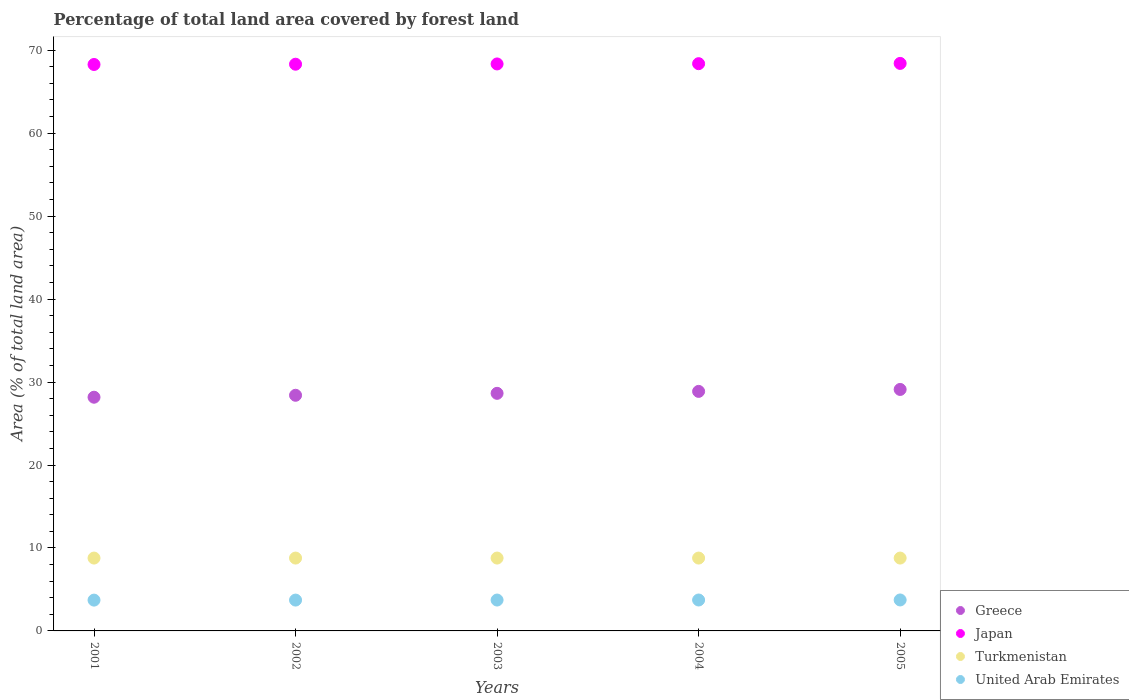Is the number of dotlines equal to the number of legend labels?
Offer a terse response. Yes. What is the percentage of forest land in Turkmenistan in 2003?
Keep it short and to the point. 8.78. Across all years, what is the maximum percentage of forest land in Greece?
Provide a succinct answer. 29.11. Across all years, what is the minimum percentage of forest land in United Arab Emirates?
Offer a very short reply. 3.71. In which year was the percentage of forest land in Greece maximum?
Your answer should be very brief. 2005. What is the total percentage of forest land in United Arab Emirates in the graph?
Make the answer very short. 18.61. What is the difference between the percentage of forest land in Greece in 2004 and that in 2005?
Your response must be concise. -0.23. What is the difference between the percentage of forest land in Greece in 2003 and the percentage of forest land in Japan in 2001?
Make the answer very short. -39.64. What is the average percentage of forest land in Greece per year?
Ensure brevity in your answer.  28.64. In the year 2005, what is the difference between the percentage of forest land in Greece and percentage of forest land in Turkmenistan?
Provide a short and direct response. 20.33. In how many years, is the percentage of forest land in Turkmenistan greater than 26 %?
Your answer should be very brief. 0. What is the ratio of the percentage of forest land in Turkmenistan in 2002 to that in 2004?
Give a very brief answer. 1. Is the percentage of forest land in Japan in 2002 less than that in 2005?
Ensure brevity in your answer.  Yes. What is the difference between the highest and the second highest percentage of forest land in Greece?
Make the answer very short. 0.23. What is the difference between the highest and the lowest percentage of forest land in United Arab Emirates?
Your answer should be compact. 0.02. Is it the case that in every year, the sum of the percentage of forest land in United Arab Emirates and percentage of forest land in Japan  is greater than the sum of percentage of forest land in Greece and percentage of forest land in Turkmenistan?
Your answer should be very brief. Yes. Is it the case that in every year, the sum of the percentage of forest land in Turkmenistan and percentage of forest land in Japan  is greater than the percentage of forest land in Greece?
Ensure brevity in your answer.  Yes. Does the percentage of forest land in Turkmenistan monotonically increase over the years?
Give a very brief answer. No. Is the percentage of forest land in Japan strictly greater than the percentage of forest land in Turkmenistan over the years?
Provide a short and direct response. Yes. How many years are there in the graph?
Your answer should be very brief. 5. Does the graph contain grids?
Your answer should be compact. No. What is the title of the graph?
Your response must be concise. Percentage of total land area covered by forest land. Does "Azerbaijan" appear as one of the legend labels in the graph?
Ensure brevity in your answer.  No. What is the label or title of the Y-axis?
Your response must be concise. Area (% of total land area). What is the Area (% of total land area) of Greece in 2001?
Offer a terse response. 28.17. What is the Area (% of total land area) of Japan in 2001?
Ensure brevity in your answer.  68.28. What is the Area (% of total land area) of Turkmenistan in 2001?
Your response must be concise. 8.78. What is the Area (% of total land area) of United Arab Emirates in 2001?
Ensure brevity in your answer.  3.71. What is the Area (% of total land area) of Greece in 2002?
Provide a succinct answer. 28.4. What is the Area (% of total land area) of Japan in 2002?
Offer a terse response. 68.31. What is the Area (% of total land area) of Turkmenistan in 2002?
Provide a short and direct response. 8.78. What is the Area (% of total land area) in United Arab Emirates in 2002?
Provide a short and direct response. 3.72. What is the Area (% of total land area) in Greece in 2003?
Your response must be concise. 28.64. What is the Area (% of total land area) in Japan in 2003?
Make the answer very short. 68.34. What is the Area (% of total land area) in Turkmenistan in 2003?
Keep it short and to the point. 8.78. What is the Area (% of total land area) of United Arab Emirates in 2003?
Your answer should be compact. 3.72. What is the Area (% of total land area) in Greece in 2004?
Provide a short and direct response. 28.87. What is the Area (% of total land area) of Japan in 2004?
Keep it short and to the point. 68.38. What is the Area (% of total land area) in Turkmenistan in 2004?
Your answer should be compact. 8.78. What is the Area (% of total land area) in United Arab Emirates in 2004?
Ensure brevity in your answer.  3.73. What is the Area (% of total land area) in Greece in 2005?
Ensure brevity in your answer.  29.11. What is the Area (% of total land area) of Japan in 2005?
Offer a very short reply. 68.41. What is the Area (% of total land area) in Turkmenistan in 2005?
Keep it short and to the point. 8.78. What is the Area (% of total land area) in United Arab Emirates in 2005?
Make the answer very short. 3.73. Across all years, what is the maximum Area (% of total land area) of Greece?
Provide a short and direct response. 29.11. Across all years, what is the maximum Area (% of total land area) in Japan?
Provide a short and direct response. 68.41. Across all years, what is the maximum Area (% of total land area) in Turkmenistan?
Keep it short and to the point. 8.78. Across all years, what is the maximum Area (% of total land area) of United Arab Emirates?
Give a very brief answer. 3.73. Across all years, what is the minimum Area (% of total land area) of Greece?
Provide a short and direct response. 28.17. Across all years, what is the minimum Area (% of total land area) in Japan?
Ensure brevity in your answer.  68.28. Across all years, what is the minimum Area (% of total land area) in Turkmenistan?
Your answer should be compact. 8.78. Across all years, what is the minimum Area (% of total land area) of United Arab Emirates?
Keep it short and to the point. 3.71. What is the total Area (% of total land area) of Greece in the graph?
Your answer should be very brief. 143.2. What is the total Area (% of total land area) in Japan in the graph?
Make the answer very short. 341.72. What is the total Area (% of total land area) in Turkmenistan in the graph?
Ensure brevity in your answer.  43.91. What is the total Area (% of total land area) in United Arab Emirates in the graph?
Give a very brief answer. 18.61. What is the difference between the Area (% of total land area) in Greece in 2001 and that in 2002?
Keep it short and to the point. -0.23. What is the difference between the Area (% of total land area) of Japan in 2001 and that in 2002?
Your answer should be compact. -0.03. What is the difference between the Area (% of total land area) in Turkmenistan in 2001 and that in 2002?
Give a very brief answer. 0. What is the difference between the Area (% of total land area) of United Arab Emirates in 2001 and that in 2002?
Keep it short and to the point. -0. What is the difference between the Area (% of total land area) in Greece in 2001 and that in 2003?
Offer a very short reply. -0.47. What is the difference between the Area (% of total land area) of Japan in 2001 and that in 2003?
Provide a succinct answer. -0.06. What is the difference between the Area (% of total land area) of Turkmenistan in 2001 and that in 2003?
Keep it short and to the point. 0. What is the difference between the Area (% of total land area) in United Arab Emirates in 2001 and that in 2003?
Ensure brevity in your answer.  -0.01. What is the difference between the Area (% of total land area) in Greece in 2001 and that in 2004?
Provide a short and direct response. -0.7. What is the difference between the Area (% of total land area) in Japan in 2001 and that in 2004?
Give a very brief answer. -0.1. What is the difference between the Area (% of total land area) in United Arab Emirates in 2001 and that in 2004?
Keep it short and to the point. -0.01. What is the difference between the Area (% of total land area) of Greece in 2001 and that in 2005?
Your answer should be compact. -0.94. What is the difference between the Area (% of total land area) in Japan in 2001 and that in 2005?
Make the answer very short. -0.13. What is the difference between the Area (% of total land area) of United Arab Emirates in 2001 and that in 2005?
Your answer should be very brief. -0.02. What is the difference between the Area (% of total land area) of Greece in 2002 and that in 2003?
Keep it short and to the point. -0.23. What is the difference between the Area (% of total land area) in Japan in 2002 and that in 2003?
Keep it short and to the point. -0.03. What is the difference between the Area (% of total land area) in United Arab Emirates in 2002 and that in 2003?
Provide a short and direct response. -0. What is the difference between the Area (% of total land area) of Greece in 2002 and that in 2004?
Offer a very short reply. -0.47. What is the difference between the Area (% of total land area) in Japan in 2002 and that in 2004?
Your answer should be compact. -0.06. What is the difference between the Area (% of total land area) of United Arab Emirates in 2002 and that in 2004?
Provide a short and direct response. -0.01. What is the difference between the Area (% of total land area) of Greece in 2002 and that in 2005?
Keep it short and to the point. -0.7. What is the difference between the Area (% of total land area) of Japan in 2002 and that in 2005?
Your response must be concise. -0.1. What is the difference between the Area (% of total land area) of Turkmenistan in 2002 and that in 2005?
Your answer should be very brief. 0. What is the difference between the Area (% of total land area) in United Arab Emirates in 2002 and that in 2005?
Your response must be concise. -0.01. What is the difference between the Area (% of total land area) of Greece in 2003 and that in 2004?
Provide a short and direct response. -0.23. What is the difference between the Area (% of total land area) of Japan in 2003 and that in 2004?
Ensure brevity in your answer.  -0.03. What is the difference between the Area (% of total land area) in Turkmenistan in 2003 and that in 2004?
Offer a terse response. 0. What is the difference between the Area (% of total land area) of United Arab Emirates in 2003 and that in 2004?
Your response must be concise. -0. What is the difference between the Area (% of total land area) in Greece in 2003 and that in 2005?
Provide a succinct answer. -0.47. What is the difference between the Area (% of total land area) of Japan in 2003 and that in 2005?
Your response must be concise. -0.06. What is the difference between the Area (% of total land area) in Turkmenistan in 2003 and that in 2005?
Give a very brief answer. 0. What is the difference between the Area (% of total land area) in United Arab Emirates in 2003 and that in 2005?
Offer a terse response. -0.01. What is the difference between the Area (% of total land area) in Greece in 2004 and that in 2005?
Provide a succinct answer. -0.23. What is the difference between the Area (% of total land area) in Japan in 2004 and that in 2005?
Your response must be concise. -0.03. What is the difference between the Area (% of total land area) in Turkmenistan in 2004 and that in 2005?
Your answer should be very brief. 0. What is the difference between the Area (% of total land area) of United Arab Emirates in 2004 and that in 2005?
Provide a short and direct response. -0. What is the difference between the Area (% of total land area) in Greece in 2001 and the Area (% of total land area) in Japan in 2002?
Make the answer very short. -40.14. What is the difference between the Area (% of total land area) in Greece in 2001 and the Area (% of total land area) in Turkmenistan in 2002?
Ensure brevity in your answer.  19.39. What is the difference between the Area (% of total land area) in Greece in 2001 and the Area (% of total land area) in United Arab Emirates in 2002?
Give a very brief answer. 24.45. What is the difference between the Area (% of total land area) in Japan in 2001 and the Area (% of total land area) in Turkmenistan in 2002?
Your response must be concise. 59.5. What is the difference between the Area (% of total land area) in Japan in 2001 and the Area (% of total land area) in United Arab Emirates in 2002?
Ensure brevity in your answer.  64.56. What is the difference between the Area (% of total land area) of Turkmenistan in 2001 and the Area (% of total land area) of United Arab Emirates in 2002?
Offer a very short reply. 5.06. What is the difference between the Area (% of total land area) in Greece in 2001 and the Area (% of total land area) in Japan in 2003?
Provide a succinct answer. -40.17. What is the difference between the Area (% of total land area) of Greece in 2001 and the Area (% of total land area) of Turkmenistan in 2003?
Provide a succinct answer. 19.39. What is the difference between the Area (% of total land area) in Greece in 2001 and the Area (% of total land area) in United Arab Emirates in 2003?
Provide a succinct answer. 24.45. What is the difference between the Area (% of total land area) of Japan in 2001 and the Area (% of total land area) of Turkmenistan in 2003?
Offer a very short reply. 59.5. What is the difference between the Area (% of total land area) in Japan in 2001 and the Area (% of total land area) in United Arab Emirates in 2003?
Keep it short and to the point. 64.56. What is the difference between the Area (% of total land area) of Turkmenistan in 2001 and the Area (% of total land area) of United Arab Emirates in 2003?
Make the answer very short. 5.06. What is the difference between the Area (% of total land area) of Greece in 2001 and the Area (% of total land area) of Japan in 2004?
Your answer should be very brief. -40.21. What is the difference between the Area (% of total land area) of Greece in 2001 and the Area (% of total land area) of Turkmenistan in 2004?
Offer a terse response. 19.39. What is the difference between the Area (% of total land area) of Greece in 2001 and the Area (% of total land area) of United Arab Emirates in 2004?
Your answer should be compact. 24.44. What is the difference between the Area (% of total land area) of Japan in 2001 and the Area (% of total land area) of Turkmenistan in 2004?
Make the answer very short. 59.5. What is the difference between the Area (% of total land area) of Japan in 2001 and the Area (% of total land area) of United Arab Emirates in 2004?
Ensure brevity in your answer.  64.55. What is the difference between the Area (% of total land area) of Turkmenistan in 2001 and the Area (% of total land area) of United Arab Emirates in 2004?
Give a very brief answer. 5.05. What is the difference between the Area (% of total land area) in Greece in 2001 and the Area (% of total land area) in Japan in 2005?
Your answer should be very brief. -40.24. What is the difference between the Area (% of total land area) in Greece in 2001 and the Area (% of total land area) in Turkmenistan in 2005?
Your answer should be very brief. 19.39. What is the difference between the Area (% of total land area) in Greece in 2001 and the Area (% of total land area) in United Arab Emirates in 2005?
Your answer should be very brief. 24.44. What is the difference between the Area (% of total land area) in Japan in 2001 and the Area (% of total land area) in Turkmenistan in 2005?
Your answer should be very brief. 59.5. What is the difference between the Area (% of total land area) in Japan in 2001 and the Area (% of total land area) in United Arab Emirates in 2005?
Ensure brevity in your answer.  64.55. What is the difference between the Area (% of total land area) of Turkmenistan in 2001 and the Area (% of total land area) of United Arab Emirates in 2005?
Provide a succinct answer. 5.05. What is the difference between the Area (% of total land area) in Greece in 2002 and the Area (% of total land area) in Japan in 2003?
Provide a succinct answer. -39.94. What is the difference between the Area (% of total land area) in Greece in 2002 and the Area (% of total land area) in Turkmenistan in 2003?
Ensure brevity in your answer.  19.62. What is the difference between the Area (% of total land area) of Greece in 2002 and the Area (% of total land area) of United Arab Emirates in 2003?
Your answer should be compact. 24.68. What is the difference between the Area (% of total land area) in Japan in 2002 and the Area (% of total land area) in Turkmenistan in 2003?
Ensure brevity in your answer.  59.53. What is the difference between the Area (% of total land area) of Japan in 2002 and the Area (% of total land area) of United Arab Emirates in 2003?
Offer a very short reply. 64.59. What is the difference between the Area (% of total land area) of Turkmenistan in 2002 and the Area (% of total land area) of United Arab Emirates in 2003?
Provide a succinct answer. 5.06. What is the difference between the Area (% of total land area) of Greece in 2002 and the Area (% of total land area) of Japan in 2004?
Make the answer very short. -39.97. What is the difference between the Area (% of total land area) of Greece in 2002 and the Area (% of total land area) of Turkmenistan in 2004?
Your answer should be very brief. 19.62. What is the difference between the Area (% of total land area) in Greece in 2002 and the Area (% of total land area) in United Arab Emirates in 2004?
Give a very brief answer. 24.68. What is the difference between the Area (% of total land area) of Japan in 2002 and the Area (% of total land area) of Turkmenistan in 2004?
Offer a very short reply. 59.53. What is the difference between the Area (% of total land area) in Japan in 2002 and the Area (% of total land area) in United Arab Emirates in 2004?
Your answer should be compact. 64.58. What is the difference between the Area (% of total land area) of Turkmenistan in 2002 and the Area (% of total land area) of United Arab Emirates in 2004?
Your response must be concise. 5.05. What is the difference between the Area (% of total land area) in Greece in 2002 and the Area (% of total land area) in Japan in 2005?
Offer a terse response. -40. What is the difference between the Area (% of total land area) in Greece in 2002 and the Area (% of total land area) in Turkmenistan in 2005?
Make the answer very short. 19.62. What is the difference between the Area (% of total land area) in Greece in 2002 and the Area (% of total land area) in United Arab Emirates in 2005?
Your answer should be compact. 24.67. What is the difference between the Area (% of total land area) of Japan in 2002 and the Area (% of total land area) of Turkmenistan in 2005?
Ensure brevity in your answer.  59.53. What is the difference between the Area (% of total land area) of Japan in 2002 and the Area (% of total land area) of United Arab Emirates in 2005?
Your response must be concise. 64.58. What is the difference between the Area (% of total land area) in Turkmenistan in 2002 and the Area (% of total land area) in United Arab Emirates in 2005?
Provide a succinct answer. 5.05. What is the difference between the Area (% of total land area) of Greece in 2003 and the Area (% of total land area) of Japan in 2004?
Offer a very short reply. -39.74. What is the difference between the Area (% of total land area) of Greece in 2003 and the Area (% of total land area) of Turkmenistan in 2004?
Make the answer very short. 19.86. What is the difference between the Area (% of total land area) of Greece in 2003 and the Area (% of total land area) of United Arab Emirates in 2004?
Your response must be concise. 24.91. What is the difference between the Area (% of total land area) of Japan in 2003 and the Area (% of total land area) of Turkmenistan in 2004?
Offer a terse response. 59.56. What is the difference between the Area (% of total land area) of Japan in 2003 and the Area (% of total land area) of United Arab Emirates in 2004?
Give a very brief answer. 64.62. What is the difference between the Area (% of total land area) in Turkmenistan in 2003 and the Area (% of total land area) in United Arab Emirates in 2004?
Your answer should be compact. 5.05. What is the difference between the Area (% of total land area) of Greece in 2003 and the Area (% of total land area) of Japan in 2005?
Make the answer very short. -39.77. What is the difference between the Area (% of total land area) in Greece in 2003 and the Area (% of total land area) in Turkmenistan in 2005?
Keep it short and to the point. 19.86. What is the difference between the Area (% of total land area) of Greece in 2003 and the Area (% of total land area) of United Arab Emirates in 2005?
Your answer should be very brief. 24.91. What is the difference between the Area (% of total land area) in Japan in 2003 and the Area (% of total land area) in Turkmenistan in 2005?
Ensure brevity in your answer.  59.56. What is the difference between the Area (% of total land area) in Japan in 2003 and the Area (% of total land area) in United Arab Emirates in 2005?
Offer a terse response. 64.61. What is the difference between the Area (% of total land area) of Turkmenistan in 2003 and the Area (% of total land area) of United Arab Emirates in 2005?
Provide a short and direct response. 5.05. What is the difference between the Area (% of total land area) of Greece in 2004 and the Area (% of total land area) of Japan in 2005?
Give a very brief answer. -39.54. What is the difference between the Area (% of total land area) of Greece in 2004 and the Area (% of total land area) of Turkmenistan in 2005?
Keep it short and to the point. 20.09. What is the difference between the Area (% of total land area) of Greece in 2004 and the Area (% of total land area) of United Arab Emirates in 2005?
Ensure brevity in your answer.  25.14. What is the difference between the Area (% of total land area) of Japan in 2004 and the Area (% of total land area) of Turkmenistan in 2005?
Your answer should be very brief. 59.59. What is the difference between the Area (% of total land area) of Japan in 2004 and the Area (% of total land area) of United Arab Emirates in 2005?
Offer a very short reply. 64.64. What is the difference between the Area (% of total land area) in Turkmenistan in 2004 and the Area (% of total land area) in United Arab Emirates in 2005?
Give a very brief answer. 5.05. What is the average Area (% of total land area) in Greece per year?
Offer a terse response. 28.64. What is the average Area (% of total land area) in Japan per year?
Your answer should be very brief. 68.34. What is the average Area (% of total land area) of Turkmenistan per year?
Your answer should be compact. 8.78. What is the average Area (% of total land area) of United Arab Emirates per year?
Offer a very short reply. 3.72. In the year 2001, what is the difference between the Area (% of total land area) in Greece and Area (% of total land area) in Japan?
Your response must be concise. -40.11. In the year 2001, what is the difference between the Area (% of total land area) in Greece and Area (% of total land area) in Turkmenistan?
Keep it short and to the point. 19.39. In the year 2001, what is the difference between the Area (% of total land area) of Greece and Area (% of total land area) of United Arab Emirates?
Your answer should be compact. 24.46. In the year 2001, what is the difference between the Area (% of total land area) of Japan and Area (% of total land area) of Turkmenistan?
Provide a short and direct response. 59.5. In the year 2001, what is the difference between the Area (% of total land area) of Japan and Area (% of total land area) of United Arab Emirates?
Make the answer very short. 64.57. In the year 2001, what is the difference between the Area (% of total land area) of Turkmenistan and Area (% of total land area) of United Arab Emirates?
Ensure brevity in your answer.  5.07. In the year 2002, what is the difference between the Area (% of total land area) in Greece and Area (% of total land area) in Japan?
Make the answer very short. -39.91. In the year 2002, what is the difference between the Area (% of total land area) in Greece and Area (% of total land area) in Turkmenistan?
Provide a succinct answer. 19.62. In the year 2002, what is the difference between the Area (% of total land area) in Greece and Area (% of total land area) in United Arab Emirates?
Your response must be concise. 24.69. In the year 2002, what is the difference between the Area (% of total land area) of Japan and Area (% of total land area) of Turkmenistan?
Provide a short and direct response. 59.53. In the year 2002, what is the difference between the Area (% of total land area) in Japan and Area (% of total land area) in United Arab Emirates?
Make the answer very short. 64.59. In the year 2002, what is the difference between the Area (% of total land area) of Turkmenistan and Area (% of total land area) of United Arab Emirates?
Make the answer very short. 5.06. In the year 2003, what is the difference between the Area (% of total land area) in Greece and Area (% of total land area) in Japan?
Your answer should be very brief. -39.7. In the year 2003, what is the difference between the Area (% of total land area) of Greece and Area (% of total land area) of Turkmenistan?
Ensure brevity in your answer.  19.86. In the year 2003, what is the difference between the Area (% of total land area) of Greece and Area (% of total land area) of United Arab Emirates?
Give a very brief answer. 24.92. In the year 2003, what is the difference between the Area (% of total land area) of Japan and Area (% of total land area) of Turkmenistan?
Offer a terse response. 59.56. In the year 2003, what is the difference between the Area (% of total land area) of Japan and Area (% of total land area) of United Arab Emirates?
Ensure brevity in your answer.  64.62. In the year 2003, what is the difference between the Area (% of total land area) of Turkmenistan and Area (% of total land area) of United Arab Emirates?
Give a very brief answer. 5.06. In the year 2004, what is the difference between the Area (% of total land area) of Greece and Area (% of total land area) of Japan?
Provide a succinct answer. -39.5. In the year 2004, what is the difference between the Area (% of total land area) of Greece and Area (% of total land area) of Turkmenistan?
Provide a short and direct response. 20.09. In the year 2004, what is the difference between the Area (% of total land area) in Greece and Area (% of total land area) in United Arab Emirates?
Your answer should be very brief. 25.15. In the year 2004, what is the difference between the Area (% of total land area) of Japan and Area (% of total land area) of Turkmenistan?
Keep it short and to the point. 59.59. In the year 2004, what is the difference between the Area (% of total land area) in Japan and Area (% of total land area) in United Arab Emirates?
Provide a succinct answer. 64.65. In the year 2004, what is the difference between the Area (% of total land area) of Turkmenistan and Area (% of total land area) of United Arab Emirates?
Your answer should be very brief. 5.05. In the year 2005, what is the difference between the Area (% of total land area) in Greece and Area (% of total land area) in Japan?
Your answer should be very brief. -39.3. In the year 2005, what is the difference between the Area (% of total land area) in Greece and Area (% of total land area) in Turkmenistan?
Your answer should be very brief. 20.33. In the year 2005, what is the difference between the Area (% of total land area) of Greece and Area (% of total land area) of United Arab Emirates?
Offer a very short reply. 25.38. In the year 2005, what is the difference between the Area (% of total land area) in Japan and Area (% of total land area) in Turkmenistan?
Your answer should be very brief. 59.63. In the year 2005, what is the difference between the Area (% of total land area) of Japan and Area (% of total land area) of United Arab Emirates?
Provide a succinct answer. 64.68. In the year 2005, what is the difference between the Area (% of total land area) in Turkmenistan and Area (% of total land area) in United Arab Emirates?
Provide a succinct answer. 5.05. What is the ratio of the Area (% of total land area) in Japan in 2001 to that in 2002?
Make the answer very short. 1. What is the ratio of the Area (% of total land area) of Greece in 2001 to that in 2003?
Ensure brevity in your answer.  0.98. What is the ratio of the Area (% of total land area) in Turkmenistan in 2001 to that in 2003?
Give a very brief answer. 1. What is the ratio of the Area (% of total land area) of Greece in 2001 to that in 2004?
Ensure brevity in your answer.  0.98. What is the ratio of the Area (% of total land area) in Japan in 2001 to that in 2004?
Offer a terse response. 1. What is the ratio of the Area (% of total land area) of Greece in 2001 to that in 2005?
Give a very brief answer. 0.97. What is the ratio of the Area (% of total land area) in Japan in 2001 to that in 2005?
Provide a short and direct response. 1. What is the ratio of the Area (% of total land area) in United Arab Emirates in 2001 to that in 2005?
Your response must be concise. 0.99. What is the ratio of the Area (% of total land area) of Greece in 2002 to that in 2003?
Give a very brief answer. 0.99. What is the ratio of the Area (% of total land area) in Japan in 2002 to that in 2003?
Your answer should be compact. 1. What is the ratio of the Area (% of total land area) in United Arab Emirates in 2002 to that in 2003?
Ensure brevity in your answer.  1. What is the ratio of the Area (% of total land area) in Greece in 2002 to that in 2004?
Provide a succinct answer. 0.98. What is the ratio of the Area (% of total land area) of Greece in 2002 to that in 2005?
Your answer should be very brief. 0.98. What is the ratio of the Area (% of total land area) of Turkmenistan in 2002 to that in 2005?
Keep it short and to the point. 1. What is the ratio of the Area (% of total land area) in United Arab Emirates in 2002 to that in 2005?
Keep it short and to the point. 1. What is the ratio of the Area (% of total land area) of United Arab Emirates in 2003 to that in 2004?
Offer a very short reply. 1. What is the ratio of the Area (% of total land area) in Greece in 2003 to that in 2005?
Your answer should be compact. 0.98. What is the ratio of the Area (% of total land area) of Japan in 2003 to that in 2005?
Give a very brief answer. 1. What is the ratio of the Area (% of total land area) of Turkmenistan in 2004 to that in 2005?
Provide a succinct answer. 1. What is the ratio of the Area (% of total land area) in United Arab Emirates in 2004 to that in 2005?
Your answer should be very brief. 1. What is the difference between the highest and the second highest Area (% of total land area) of Greece?
Keep it short and to the point. 0.23. What is the difference between the highest and the second highest Area (% of total land area) in Japan?
Your answer should be compact. 0.03. What is the difference between the highest and the second highest Area (% of total land area) of Turkmenistan?
Provide a succinct answer. 0. What is the difference between the highest and the second highest Area (% of total land area) of United Arab Emirates?
Your answer should be very brief. 0. What is the difference between the highest and the lowest Area (% of total land area) in Greece?
Give a very brief answer. 0.94. What is the difference between the highest and the lowest Area (% of total land area) of Japan?
Ensure brevity in your answer.  0.13. What is the difference between the highest and the lowest Area (% of total land area) of United Arab Emirates?
Give a very brief answer. 0.02. 